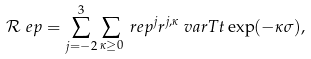<formula> <loc_0><loc_0><loc_500><loc_500>& \mathcal { R } ^ { \ } e p = \sum _ { j = - 2 } ^ { 3 } \sum _ { \kappa \geq 0 } \ r e p ^ { j } r ^ { j , \kappa } \ v a r T t \exp ( - \kappa \sigma ) ,</formula> 